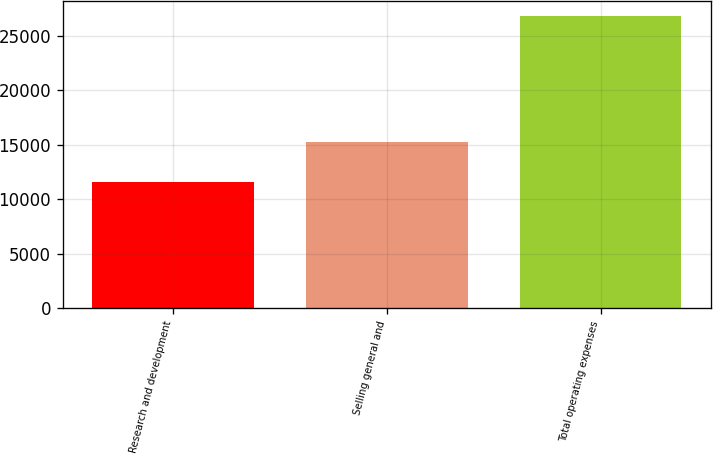<chart> <loc_0><loc_0><loc_500><loc_500><bar_chart><fcel>Research and development<fcel>Selling general and<fcel>Total operating expenses<nl><fcel>11581<fcel>15261<fcel>26842<nl></chart> 